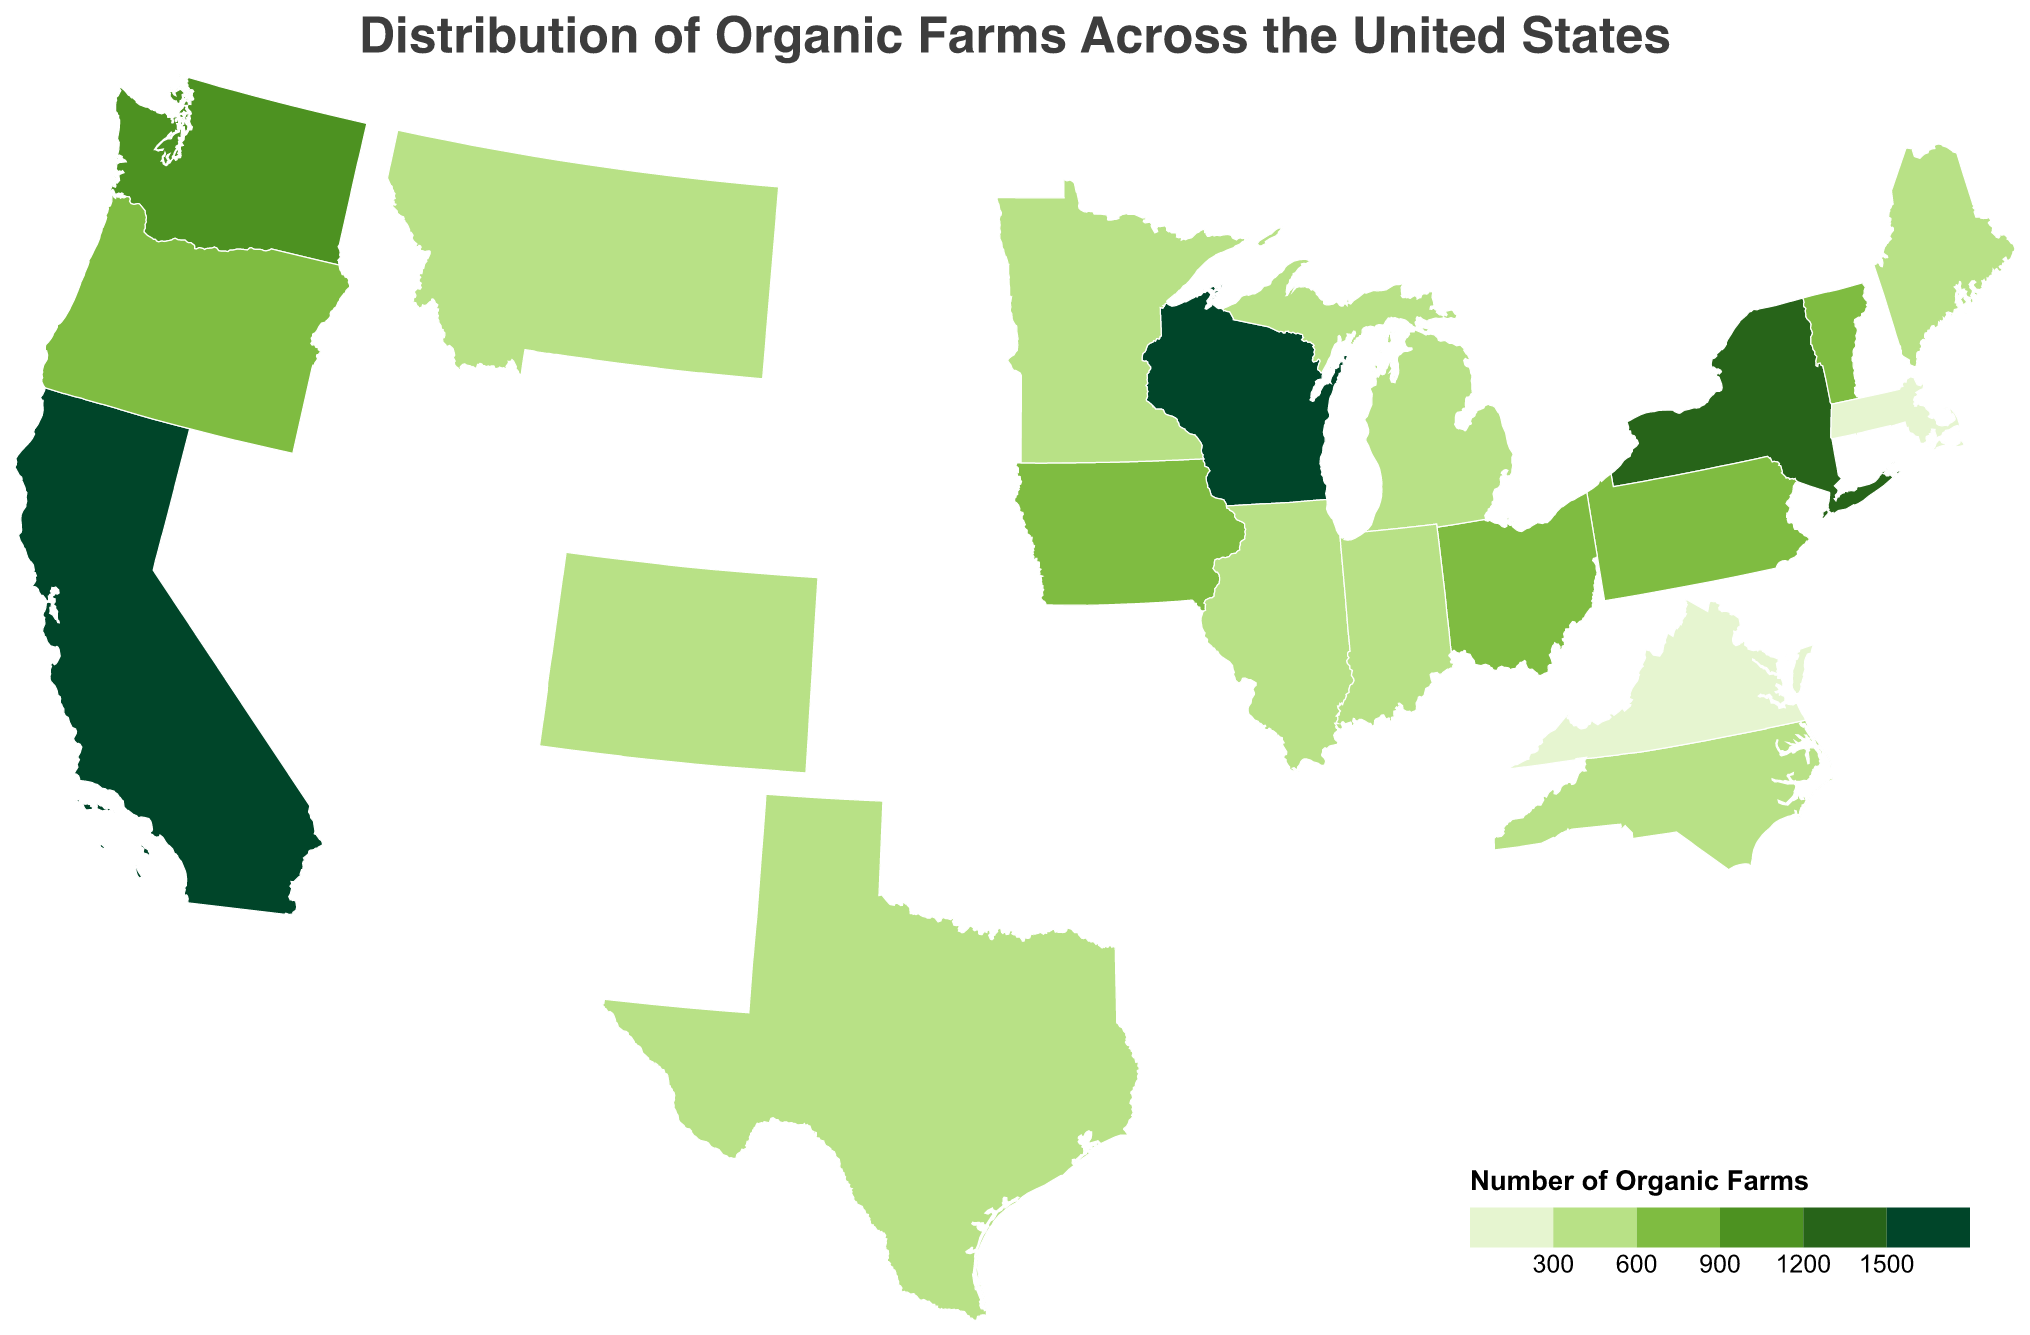Which state has the highest number of organic farms? By observing the color intensity, California stands out as having the darkest shade, indicating the highest number. The tooltip confirms this with a count of 3635 organic farms.
Answer: California Which state has the second highest percentage of organic farms? By looking at the tooltip information, Wisconsin is shown to have the second highest percentage at 6.8%, following California which has 14.8%.
Answer: Wisconsin How does the number of organic farms in New York compare to that in Oregon? New York is shown to have 1321 organic farms while Oregon has 864. By comparing these values, New York has more.
Answer: New York has more What is the combined percentage of total farms for Washington and Pennsylvania? Washington has 4.7% and Pennsylvania has 3.3%. Adding these together, 4.7 + 3.3 = 8%.
Answer: 8% How many states have an organic farms count greater than 1000? Based on the plot's data, these states are California (3635), Wisconsin (1677), New York (1321), and Washington (1158). Counting them results in 4 states.
Answer: 4 states Which state has the least number of organic farms among those listed? The state with the lightest color shade on the plot has the least number. From the tooltip, Virginia has 283 organic farms, which is the lowest count among the listed states.
Answer: Virginia What's the difference in the count of organic farms between Texas and Vermont? Texas has 469 organic farms while Vermont has 724. The difference is calculated as 724 - 469 = 255.
Answer: 255 What is the percentage of total farms that are organic in Texas? By looking at the tooltip information for Texas, the percentage of total farms that are organic is shown to be 1.9%.
Answer: 1.9% How does the concentration of organic farms in California compare to those in Ohio and Iowa combined? California has 3635 organic farms. Ohio has 785 and Iowa has 779, their combined count is 785 + 779 = 1564. California has significantly more organic farms.
Answer: California has more Which states have an organic farms count between 500 and 800? States with counts in this range are Pennsylvania (803), Ohio (785), Iowa (779), Vermont (724), Minnesota (545), and Maine (535).
Answer: Pennsylvania, Ohio, Iowa, Vermont, Minnesota, and Maine 